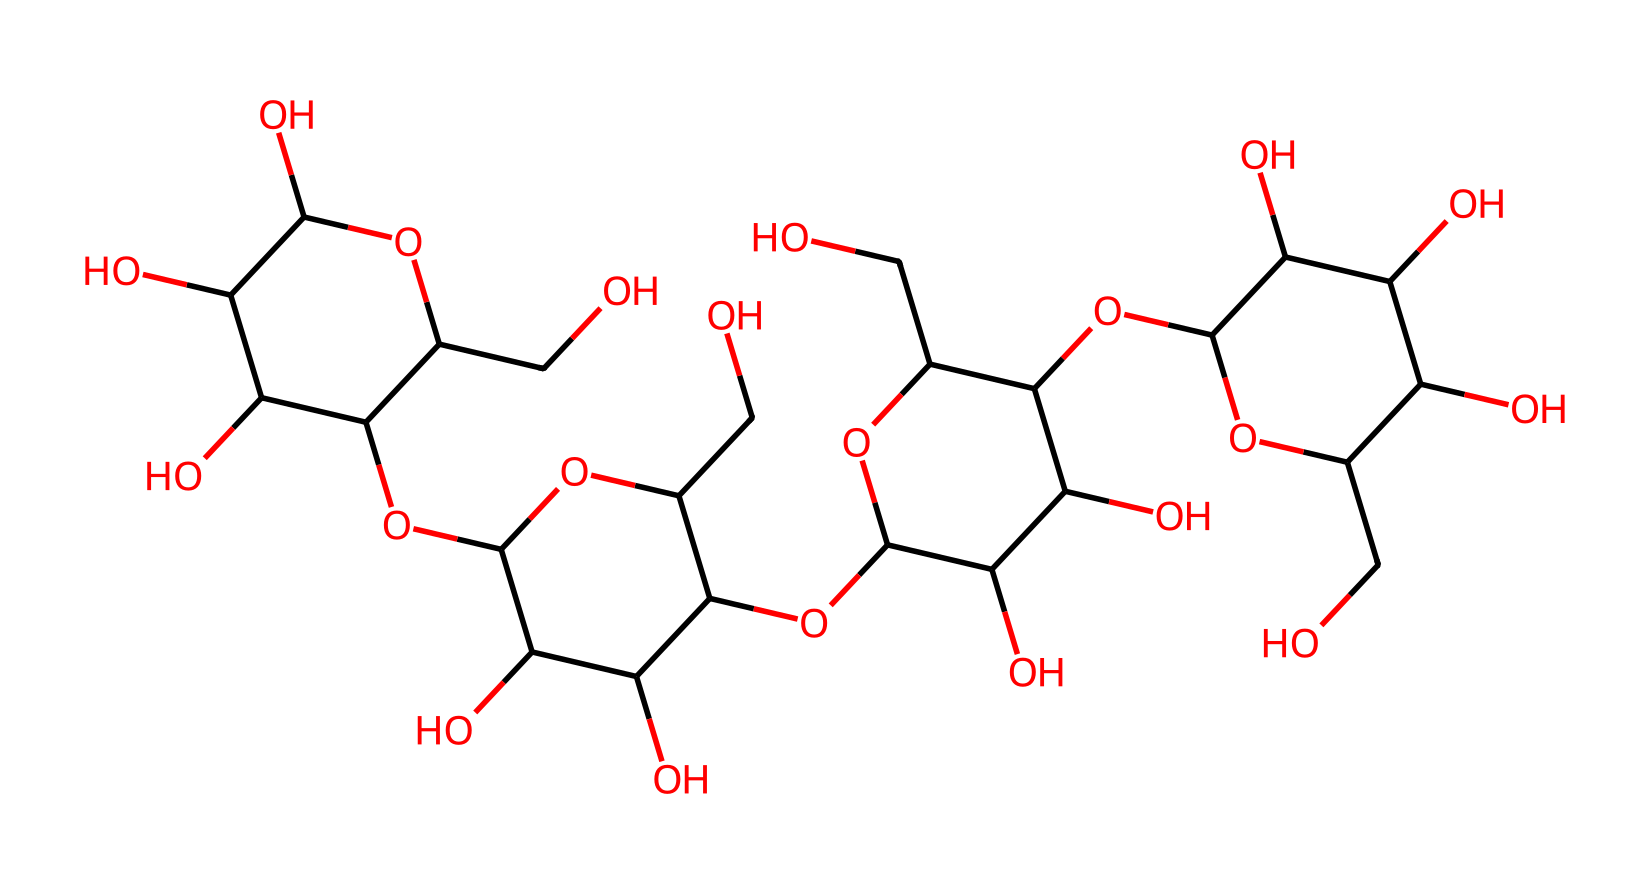What is the primary molecule type in this structure? The structure contains multiple hydroxyl groups (–OH) that typically indicate it is a carbohydrate, specifically polysaccharide, as it is primarily composed of glucose units derived from starch.
Answer: polysaccharide How many carbon atoms are in the structure? By analyzing the SMILES representation, counting each carbon atom yields a total of 12 carbon atoms present in separate sugar units comprising the polysaccharide structure.
Answer: 12 Does this chemical exhibit thixotropic properties? Non-Newtonian fluids like oobleck, which is primarily made from cornstarch, often exhibit shear-thinning behavior, indicating thixotropic properties when disturbed, such as by stirring.
Answer: yes What is the molecular weight of cornstarch? Given that the base unit of cornstarch typically has an average molecular weight of approximately 162 grams per mole when considering the glucose units' contributions in polysaccharide form.
Answer: 162 How does the presence of hydroxyl groups affect its viscosity? Hydroxyl groups increase intermolecular hydrogen bonding in the polysaccharide, enhancing the structure's viscosity when a force is applied. The inherent structure leads to increased resistance to flow, typical of non-Newtonian behavior.
Answer: increases viscosity 